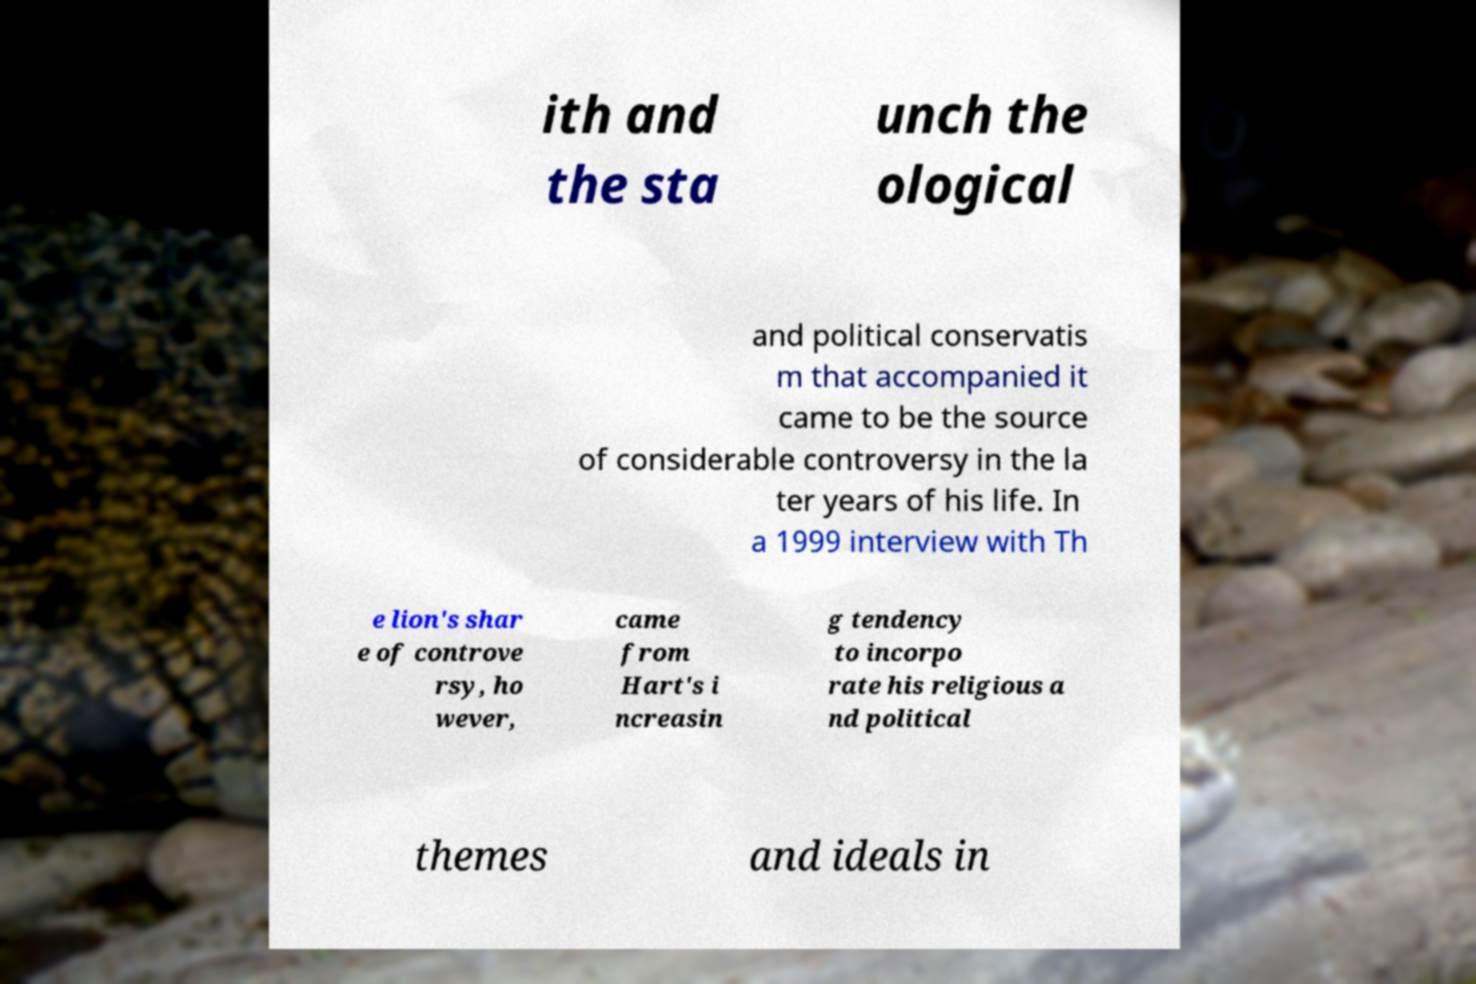There's text embedded in this image that I need extracted. Can you transcribe it verbatim? ith and the sta unch the ological and political conservatis m that accompanied it came to be the source of considerable controversy in the la ter years of his life. In a 1999 interview with Th e lion's shar e of controve rsy, ho wever, came from Hart's i ncreasin g tendency to incorpo rate his religious a nd political themes and ideals in 